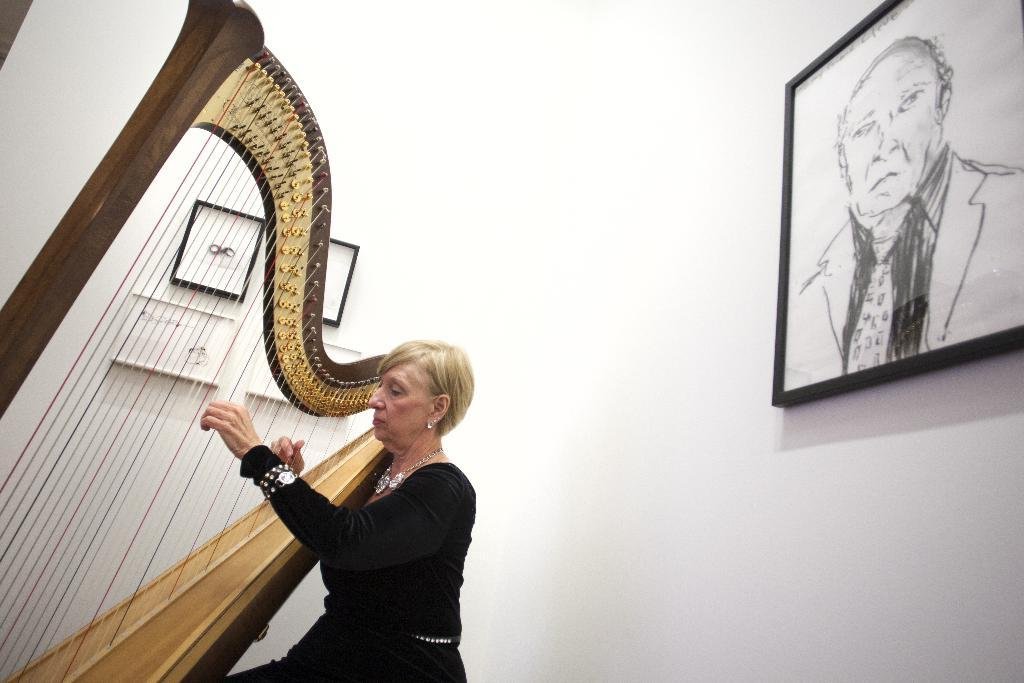Who is the main subject in the image? There is a woman in the image. What is the woman wearing? The woman is wearing a black dress. What is the woman doing in the image? The woman is playing a musical instrument. What can be seen in the background of the image? There is a white wall in the background of the image. What is placed on the white wall? Many photo frames are placed on the white wall. What type of hill can be seen in the background of the image? There is no hill present in the background of the image; it features a white wall with photo frames. Is there a jail visible in the image? There is no jail present in the image; it features a woman playing a musical instrument and a white wall with photo frames. 